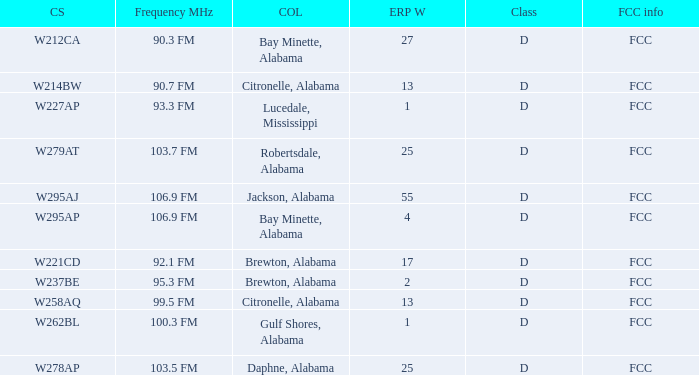Name the FCC info for call sign of w279at FCC. 